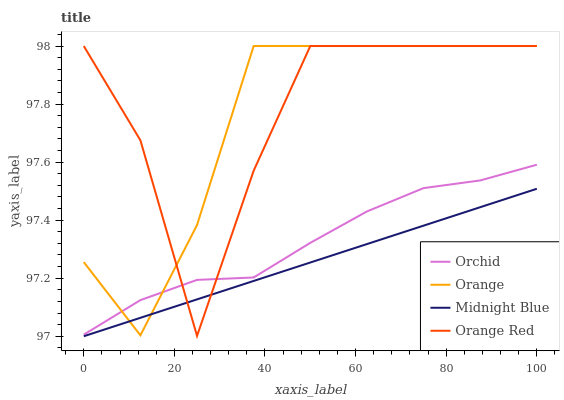Does Midnight Blue have the minimum area under the curve?
Answer yes or no. Yes. Does Orange Red have the maximum area under the curve?
Answer yes or no. Yes. Does Orange Red have the minimum area under the curve?
Answer yes or no. No. Does Midnight Blue have the maximum area under the curve?
Answer yes or no. No. Is Midnight Blue the smoothest?
Answer yes or no. Yes. Is Orange Red the roughest?
Answer yes or no. Yes. Is Orange Red the smoothest?
Answer yes or no. No. Is Midnight Blue the roughest?
Answer yes or no. No. Does Midnight Blue have the lowest value?
Answer yes or no. Yes. Does Orange Red have the lowest value?
Answer yes or no. No. Does Orange Red have the highest value?
Answer yes or no. Yes. Does Midnight Blue have the highest value?
Answer yes or no. No. Is Midnight Blue less than Orchid?
Answer yes or no. Yes. Is Orchid greater than Midnight Blue?
Answer yes or no. Yes. Does Orange intersect Orchid?
Answer yes or no. Yes. Is Orange less than Orchid?
Answer yes or no. No. Is Orange greater than Orchid?
Answer yes or no. No. Does Midnight Blue intersect Orchid?
Answer yes or no. No. 